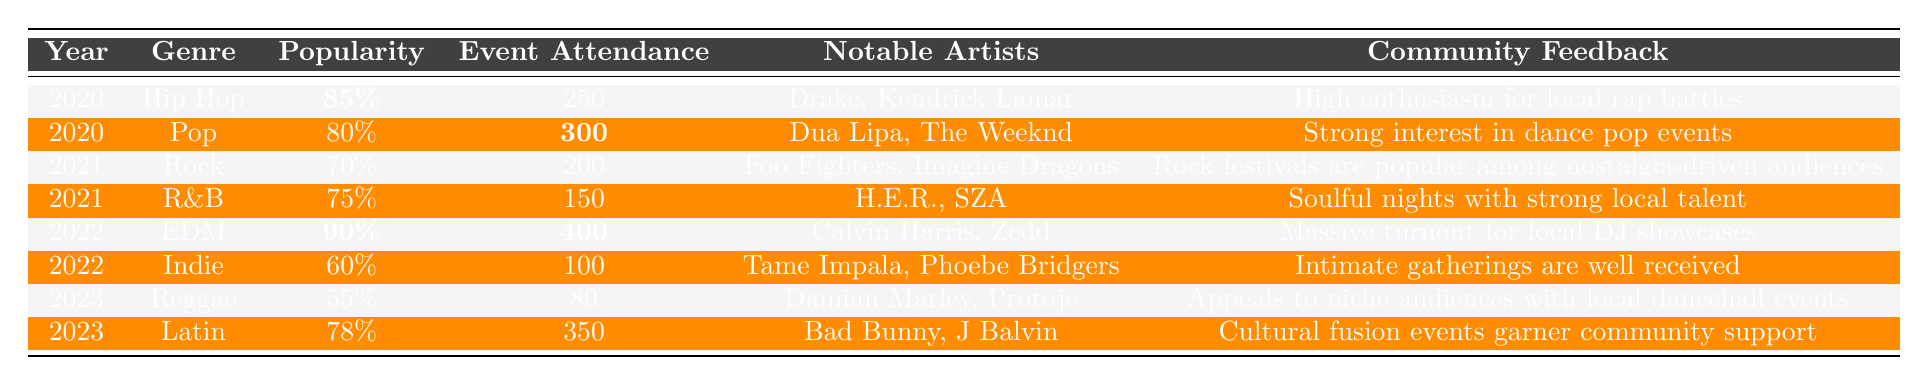What genre had the highest popularity in 2022? In 2022, the genre with the highest popularity is **EDM**, which registered a popularity of **90%**.
Answer: EDM How many people attended the Pop event in 2020? The attendance for the Pop event in 2020 was **300** people.
Answer: 300 Which genres experienced an increase in popularity from 2021 to 2022? Comparing 2021 and 2022, **EDM** increased from **N/A** to **90%** and **R&B** stayed at **75%**, so only EDM shows an increase.
Answer: EDM Was the Event Attendance for Reggae in 2023 higher than that of Rock in 2021? The Reggae event attendance in 2023 was **80**, which is lower than the Rock event attendance of **200** in 2021.
Answer: No What is the average popularity of all music genres in 2020? The total popularity for genres in 2020 is (85 + 80) = 165%. Dividing by the number of genres (2), the average popularity is **82.5%**.
Answer: 82.5% Which years had events with an attendance of over 300 people? The years with attendance over 300 are **2020 (Pop with 300)** and **2022 (EDM with 400)**.
Answer: 2020, 2022 List the notable artists for the Latin genre in 2023. The notable artists for Latin in 2023 are **Bad Bunny** and **J Balvin**.
Answer: Bad Bunny, J Balvin What percentage did the popularity of Reggae drop compared to EDM in 2022? The popularity of EDM in 2022 is **90%**, while Reggae in 2023 is **55%**, showing a drop of (90 - 55 = 35)%.
Answer: 35% How does the community feedback for the Indie genre in 2022 compare to that of EDM in 2022? The feedback for Indie in 2022 describes events as "well received," while EDM had "massive turnout," suggesting stronger enthusiasm for EDM.
Answer: EDM had stronger enthusiasm What was the community feedback for R&B in 2021? The community feedback for R&B in 2021 was "Soulful nights with strong local talent."
Answer: Soulful nights with strong local talent 